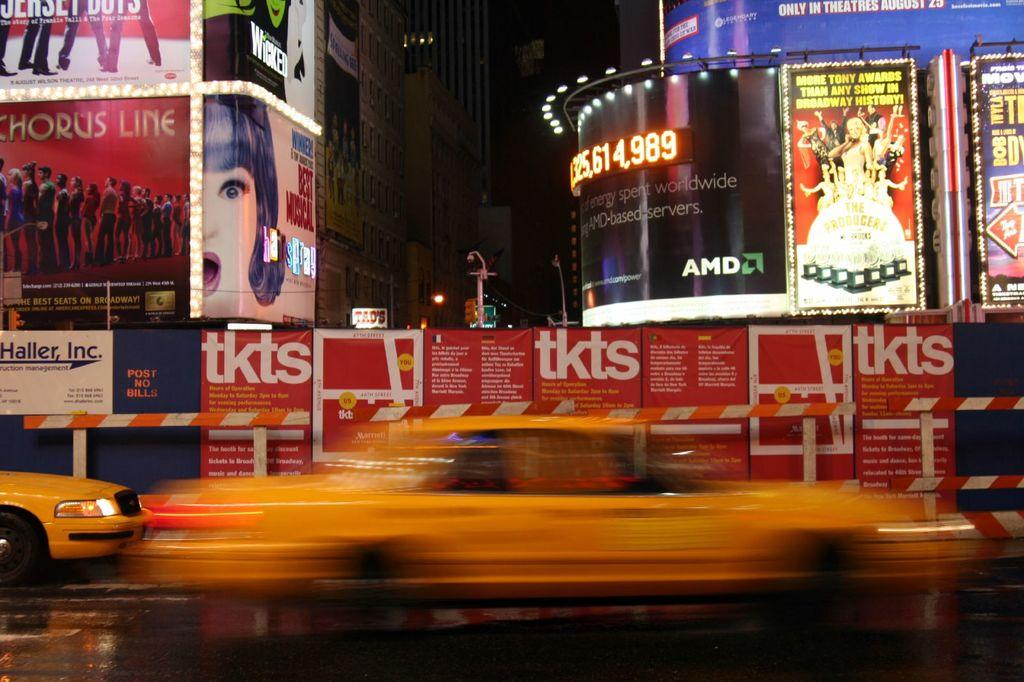<image>
Present a compact description of the photo's key features. A yellow cab speeds past tkts posters on the sidewalk. 